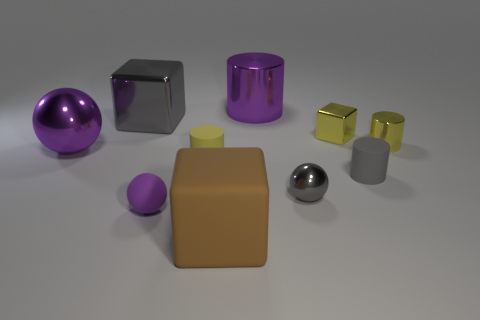Subtract 1 cylinders. How many cylinders are left? 3 Subtract all balls. How many objects are left? 7 Subtract 0 red balls. How many objects are left? 10 Subtract all yellow shiny objects. Subtract all purple balls. How many objects are left? 6 Add 3 yellow rubber objects. How many yellow rubber objects are left? 4 Add 9 small green shiny spheres. How many small green shiny spheres exist? 9 